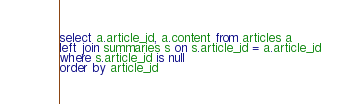<code> <loc_0><loc_0><loc_500><loc_500><_SQL_>select a.article_id, a.content from articles a
left join summaries s on s.article_id = a.article_id
where s.article_id is null
order by article_id</code> 